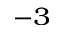Convert formula to latex. <formula><loc_0><loc_0><loc_500><loc_500>^ { - 3 }</formula> 